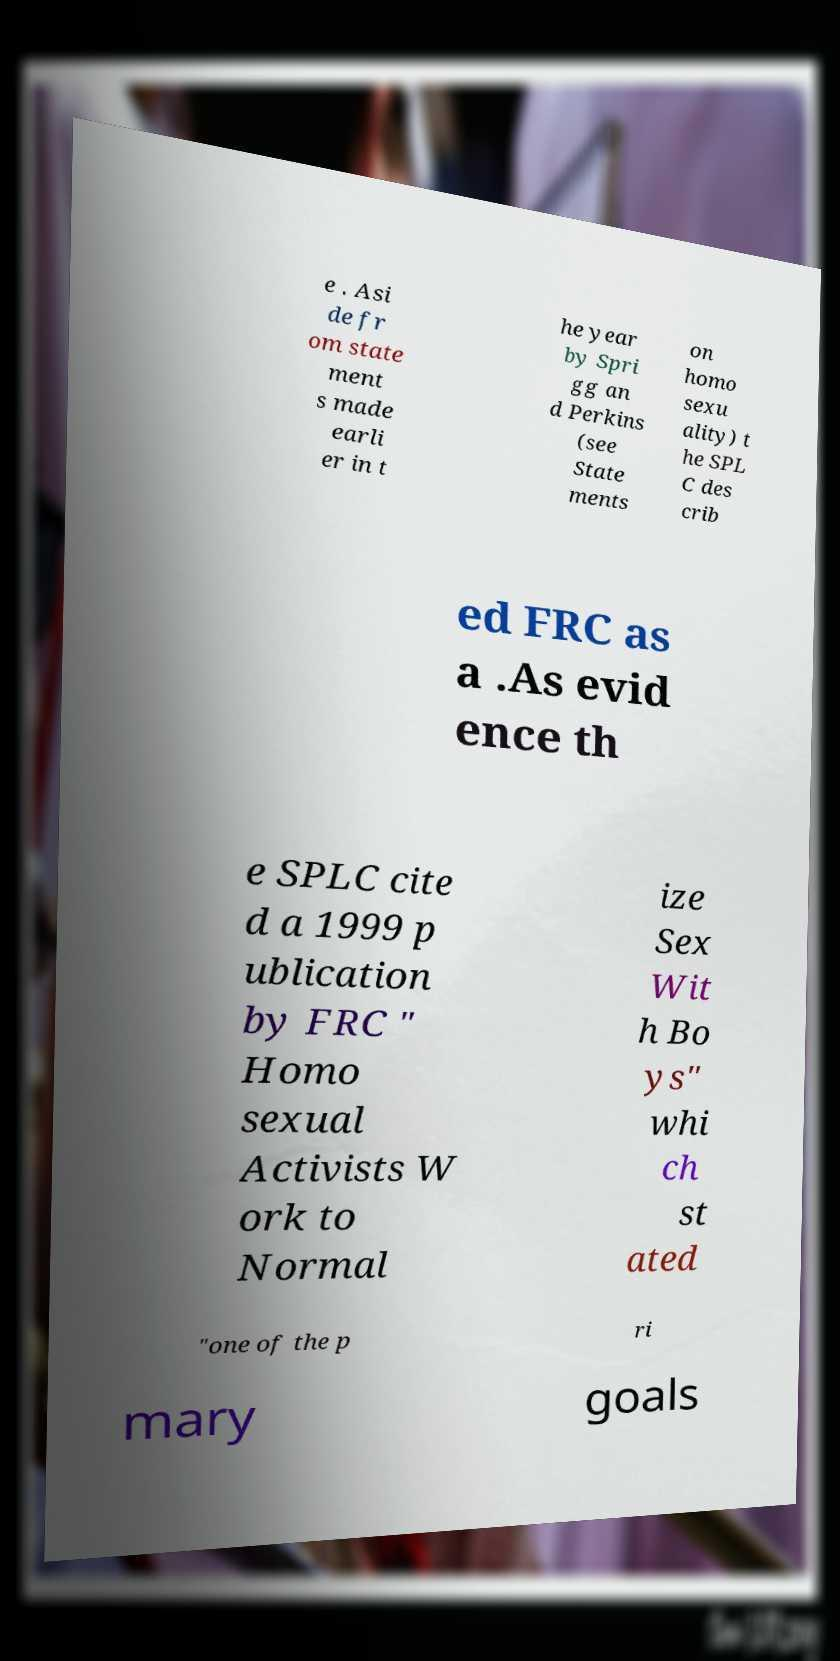I need the written content from this picture converted into text. Can you do that? e . Asi de fr om state ment s made earli er in t he year by Spri gg an d Perkins (see State ments on homo sexu ality) t he SPL C des crib ed FRC as a .As evid ence th e SPLC cite d a 1999 p ublication by FRC " Homo sexual Activists W ork to Normal ize Sex Wit h Bo ys" whi ch st ated "one of the p ri mary goals 